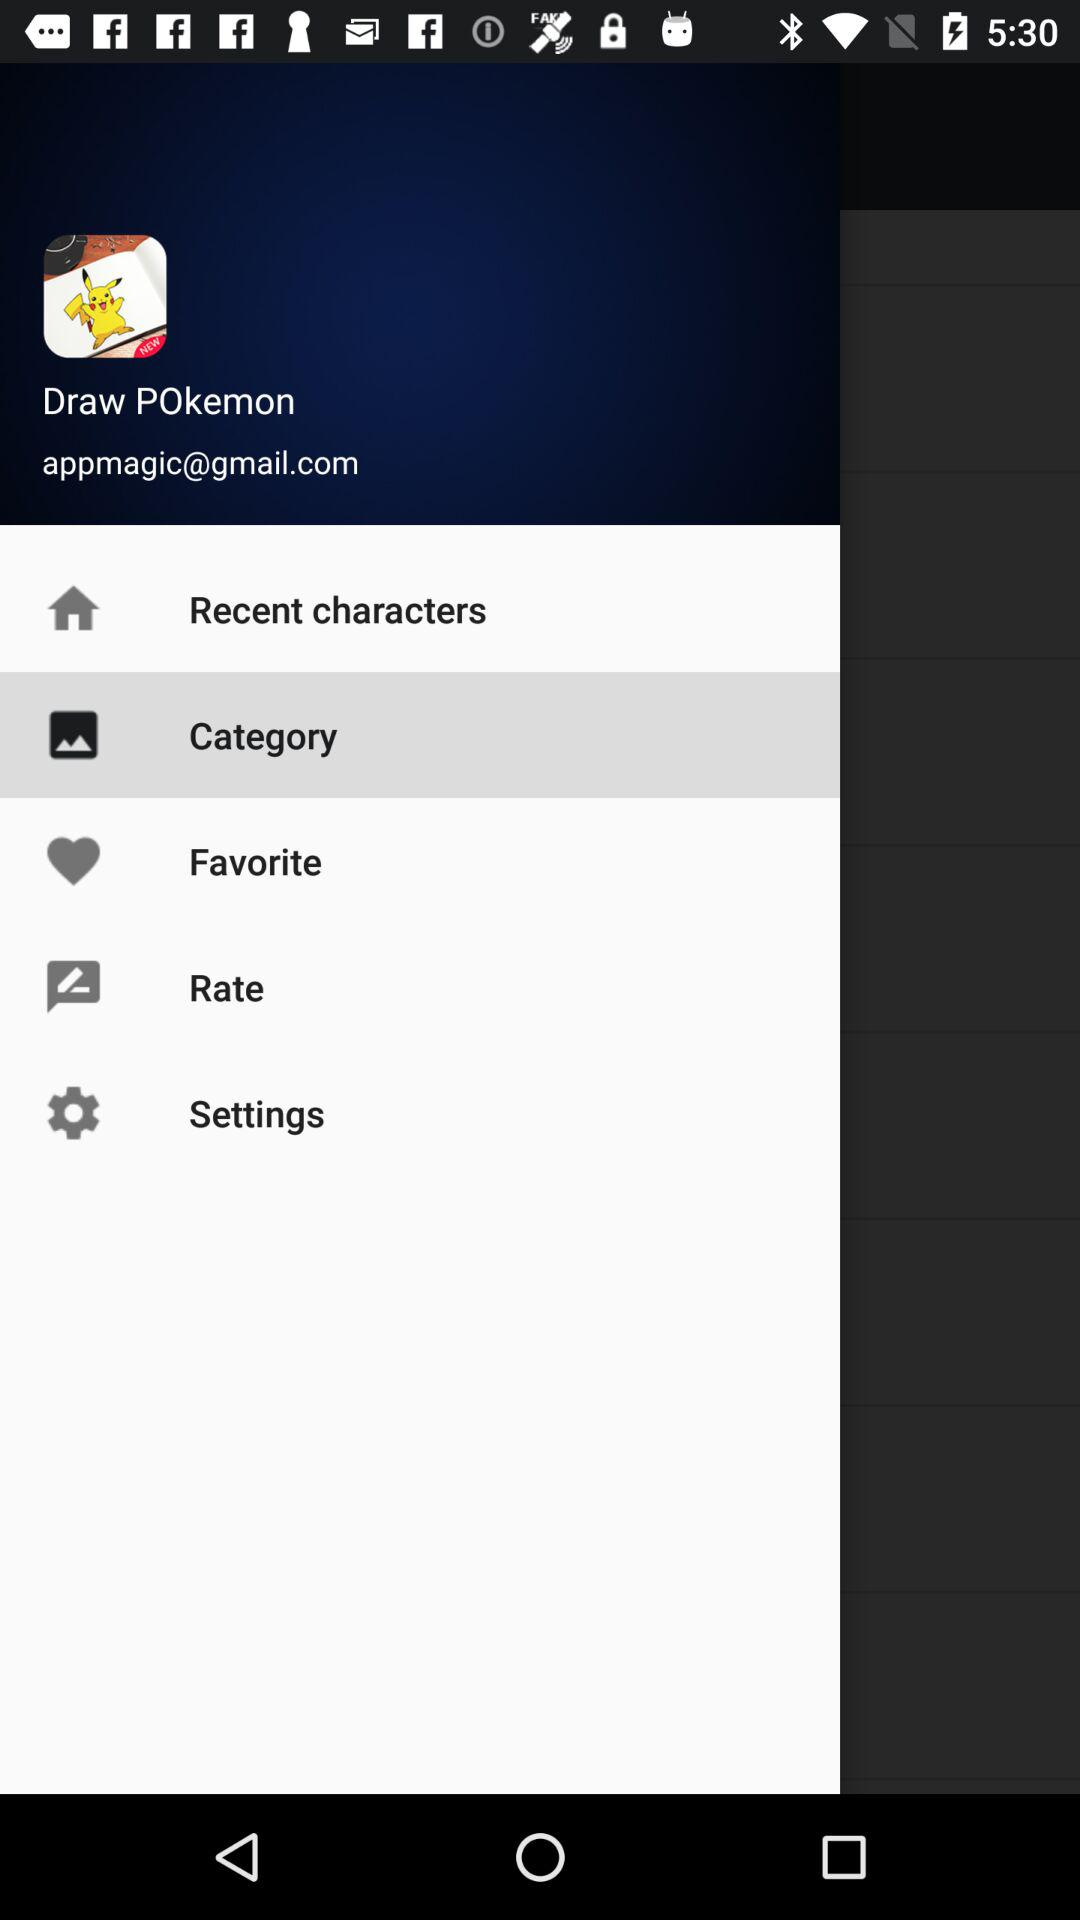What is the mail address provided? The provided mail address is appmagic@gmail.com. 